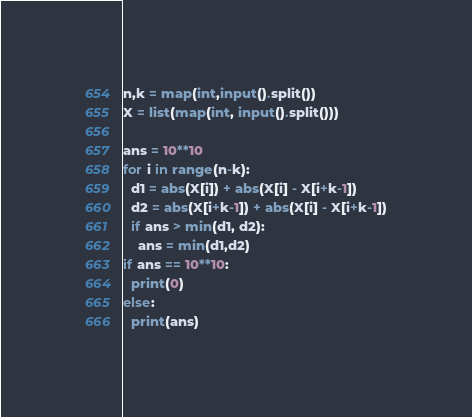Convert code to text. <code><loc_0><loc_0><loc_500><loc_500><_Python_>n,k = map(int,input().split())
X = list(map(int, input().split()))

ans = 10**10
for i in range(n-k):
  d1 = abs(X[i]) + abs(X[i] - X[i+k-1])
  d2 = abs(X[i+k-1]) + abs(X[i] - X[i+k-1])
  if ans > min(d1, d2):
    ans = min(d1,d2)
if ans == 10**10:
  print(0)
else:
  print(ans)


</code> 